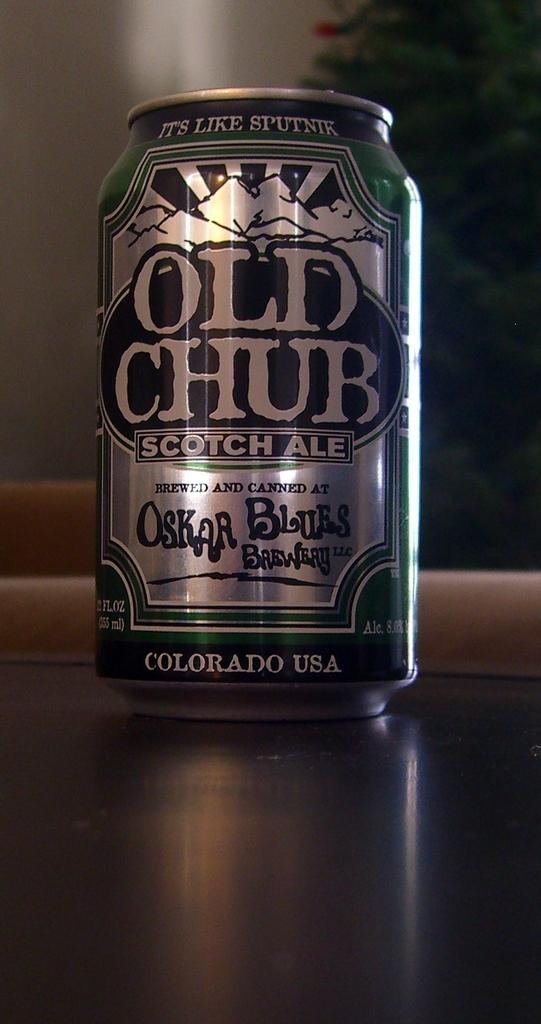<image>
Present a compact description of the photo's key features. A can of Old Chub scotch ale sitting on a wooden table. 